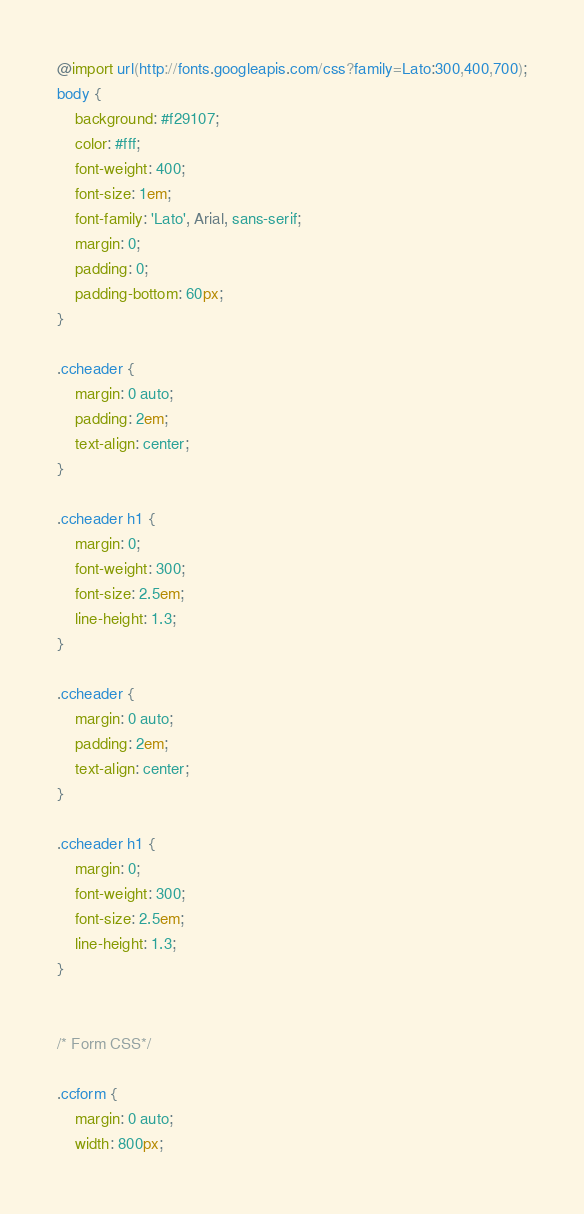<code> <loc_0><loc_0><loc_500><loc_500><_CSS_>@import url(http://fonts.googleapis.com/css?family=Lato:300,400,700);
body {
    background: #f29107;
    color: #fff;
    font-weight: 400;
    font-size: 1em;
    font-family: 'Lato', Arial, sans-serif;
    margin: 0;
    padding: 0;
    padding-bottom: 60px;
}

.ccheader {
    margin: 0 auto;
    padding: 2em;
    text-align: center;
}

.ccheader h1 {
    margin: 0;
    font-weight: 300;
    font-size: 2.5em;
    line-height: 1.3;
}

.ccheader {
    margin: 0 auto;
    padding: 2em;
    text-align: center;
}

.ccheader h1 {
    margin: 0;
    font-weight: 300;
    font-size: 2.5em;
    line-height: 1.3;
}


/* Form CSS*/

.ccform {
    margin: 0 auto;
    width: 800px;</code> 